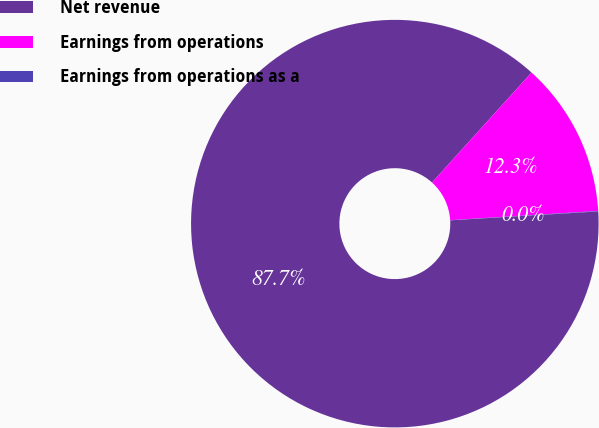<chart> <loc_0><loc_0><loc_500><loc_500><pie_chart><fcel>Net revenue<fcel>Earnings from operations<fcel>Earnings from operations as a<nl><fcel>87.66%<fcel>12.3%<fcel>0.04%<nl></chart> 